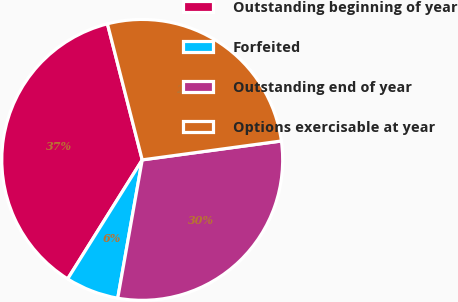Convert chart. <chart><loc_0><loc_0><loc_500><loc_500><pie_chart><fcel>Outstanding beginning of year<fcel>Forfeited<fcel>Outstanding end of year<fcel>Options exercisable at year<nl><fcel>37.11%<fcel>6.12%<fcel>29.94%<fcel>26.84%<nl></chart> 